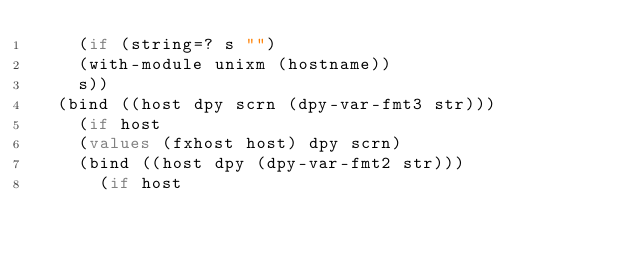<code> <loc_0><loc_0><loc_500><loc_500><_Scheme_>    (if (string=? s "")
	(with-module unixm (hostname))
	s))
  (bind ((host dpy scrn (dpy-var-fmt3 str)))
    (if host
	(values (fxhost host) dpy scrn)
	(bind ((host dpy (dpy-var-fmt2 str)))
	  (if host</code> 